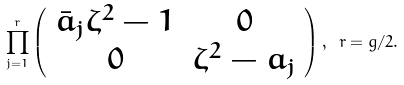Convert formula to latex. <formula><loc_0><loc_0><loc_500><loc_500>\prod _ { j = 1 } ^ { r } \left ( \begin{array} { c c } \bar { a } _ { j } \zeta ^ { 2 } - 1 & 0 \\ 0 & \zeta ^ { 2 } - a _ { j } \end{array} \right ) , \ r = g / 2 .</formula> 